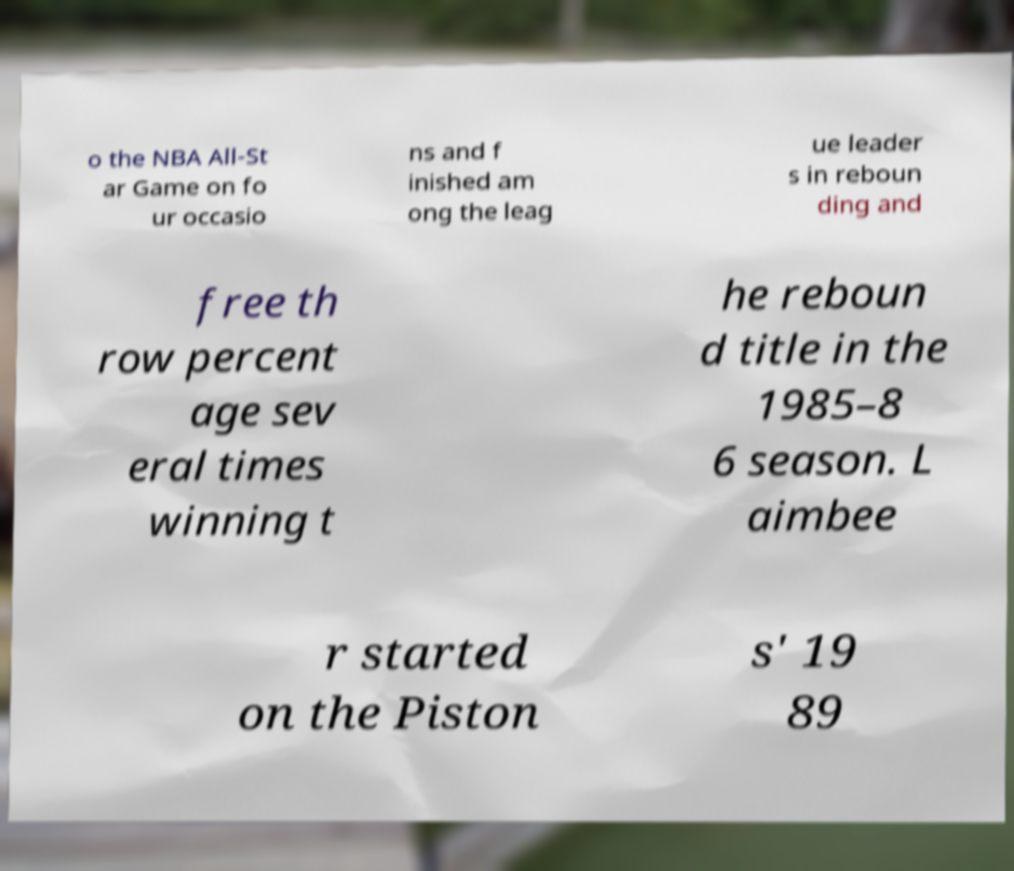Please identify and transcribe the text found in this image. o the NBA All-St ar Game on fo ur occasio ns and f inished am ong the leag ue leader s in reboun ding and free th row percent age sev eral times winning t he reboun d title in the 1985–8 6 season. L aimbee r started on the Piston s' 19 89 